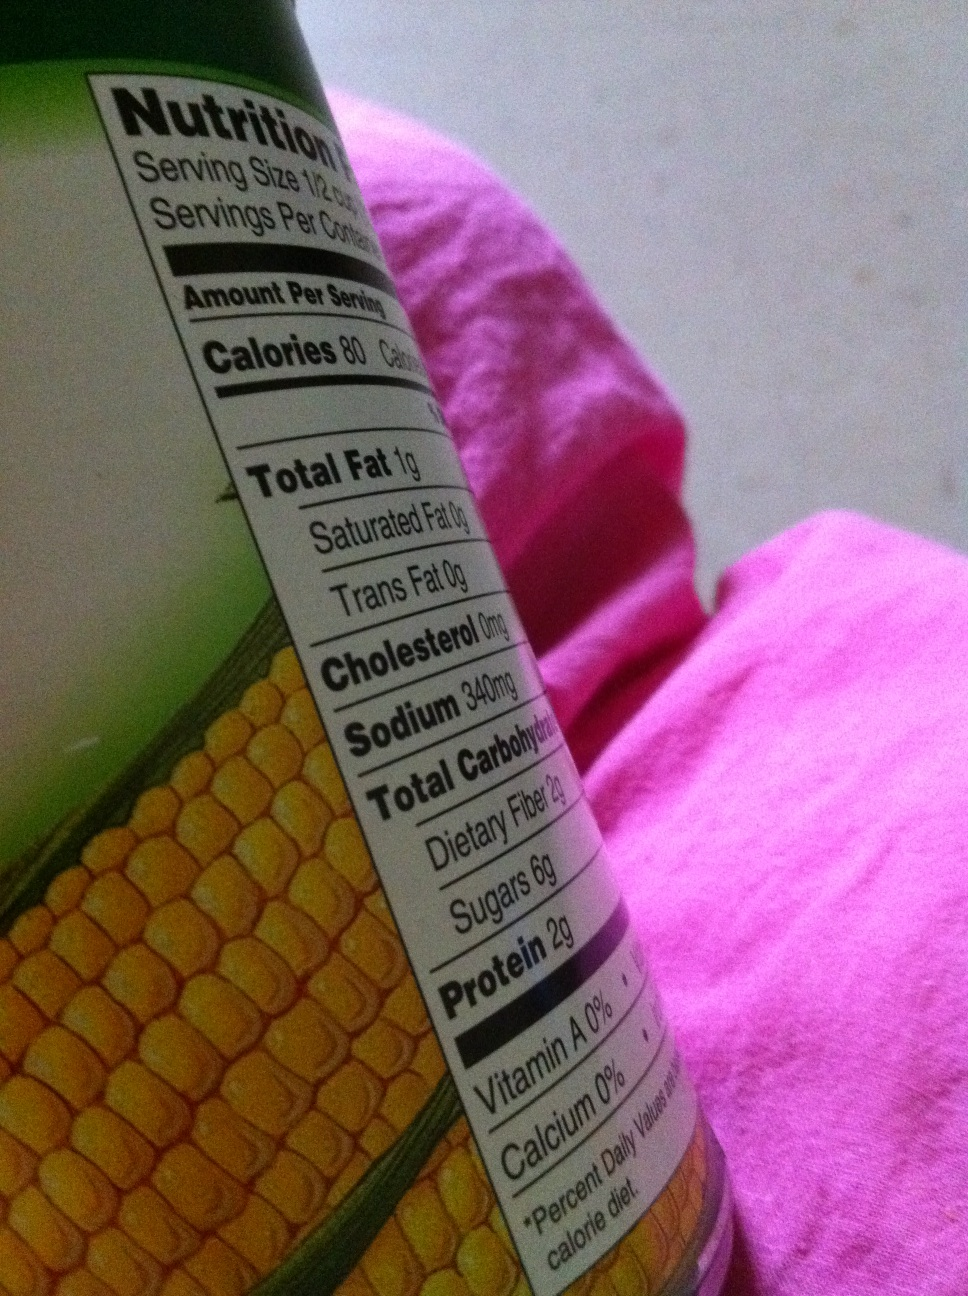Can you tell me more about what's inside the can based on the label? While the image doesn't show the entire label, the visible nutrition facts and the image of corn suggest that the can likely contains corn. It lists 80 calories per serving, 1 gram of total fat, and notable amounts of sodium and carbohydrates, which are typical nutritional values for canned corn. 